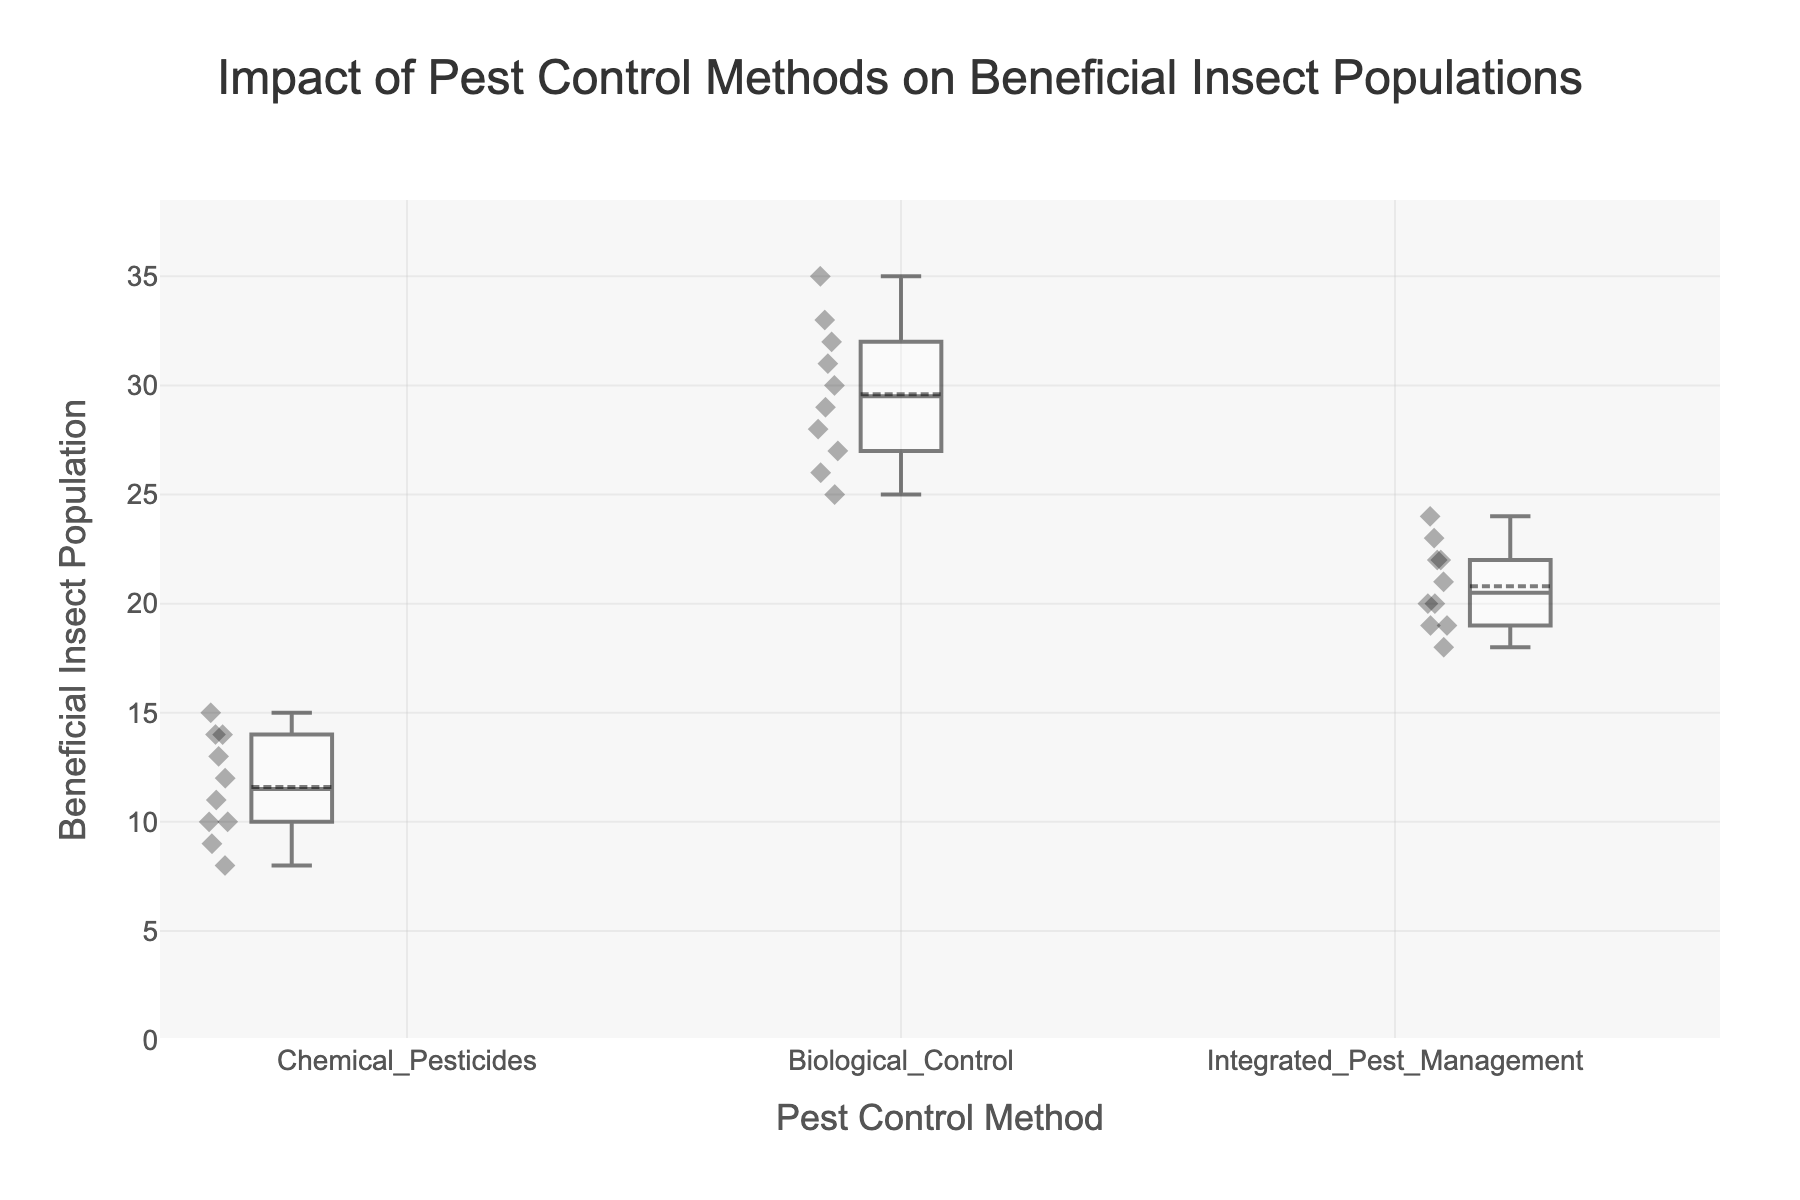What is the title of the figure? The title of the figure appears clearly at the top of the plot, describing what the figure is about.
Answer: Impact of Pest Control Methods on Beneficial Insect Populations Which pest control method has the highest median beneficial insect population? By looking at the middle line inside each box plot, which represents the median, we can see the highest value. The median line for Biological Control is the highest among the three methods.
Answer: Biological Control Which pest control method has the widest range of beneficial insect populations? The range can be determined by the difference between the top whisker and the bottom whisker of each box plot. Biological Control has the widest range as the distance between its top and bottom whiskers is the largest.
Answer: Biological Control What is the approximate median beneficial insect population for Integrated Pest Management (IPM)? The median is indicated by the line within the box for Integrated Pest Management. Visually, it looks to be between 20 and 21.
Answer: 21 Compare the average beneficial insect populations between Chemical Pesticides and Biological Control. Which one is higher? The box plots show the statistical parameters. The mean is indicated by a small line or point within each box. The mean for Biological Control is visibly higher than that for Chemical Pesticides.
Answer: Biological Control How many data points are there for each pest control method? Each jittered point within the box plot represents a data point. Counting these points for each method shows that there are 10 data points for each pest control method in the graph.
Answer: 10 What is the minimum beneficial insect population observed for Chemical Pesticides? The minimum value is represented by the bottom whisker of the box plot. For Chemical Pesticides, this is the lowest point.
Answer: 8 Which pest control method has the smallest interquartile range (IQR) for beneficial insect populations, and what might this imply? The IQR is the box's height, defined by the 25th to 75th percentile values. Integrated Pest Management has the smallest IQR, indicating it has the most consistent insect population values.
Answer: Integrated Pest Management What can be inferred about the variability in the beneficial insect populations under Biological Control compared to Chemical Pesticides? The height of the box and length of the whiskers reflect variability. Biological Control's larger box and whiskers indicate higher variability compared to Chemical Pesticides' smaller and more compact box.
Answer: Biological Control has higher variability 